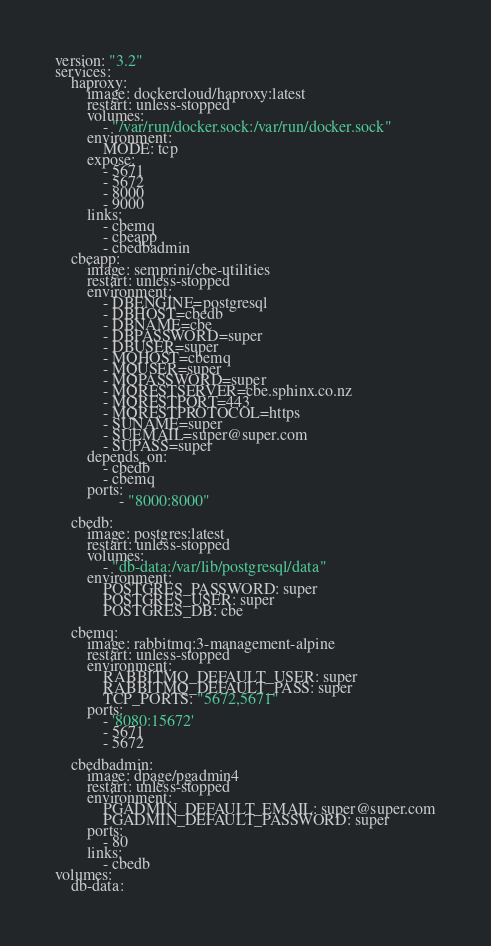<code> <loc_0><loc_0><loc_500><loc_500><_YAML_>version: "3.2"
services:
    haproxy:
        image: dockercloud/haproxy:latest
        restart: unless-stopped
        volumes:
            - "/var/run/docker.sock:/var/run/docker.sock"
        environment:
            MODE: tcp
        expose:
            - 5671
            - 5672
            - 8000
            - 9000
        links:
            - cbemq
            - cbeapp
            - cbedbadmin
    cbeapp:
        image: semprini/cbe-utilities
        restart: unless-stopped
        environment:
            - DBENGINE=postgresql
            - DBHOST=cbedb
            - DBNAME=cbe
            - DBPASSWORD=super
            - DBUSER=super
            - MQHOST=cbemq
            - MQUSER=super
            - MQPASSWORD=super
            - MQRESTSERVER=cbe.sphinx.co.nz
            - MQRESTPORT=443
            - MQRESTPROTOCOL=https
            - SUNAME=super
            - SUEMAIL=super@super.com
            - SUPASS=super
        depends_on:
            - cbedb
            - cbemq
        ports:
                - "8000:8000"
            
    cbedb:
        image: postgres:latest
        restart: unless-stopped
        volumes:
            - "db-data:/var/lib/postgresql/data"
        environment:
            POSTGRES_PASSWORD: super
            POSTGRES_USER: super
            POSTGRES_DB: cbe
            
    cbemq:
        image: rabbitmq:3-management-alpine
        restart: unless-stopped
        environment:
            RABBITMQ_DEFAULT_USER: super
            RABBITMQ_DEFAULT_PASS: super
            TCP_PORTS: "5672,5671"
        ports:
            - '8080:15672'
            - 5671
            - 5672

    cbedbadmin:
        image: dpage/pgadmin4
        restart: unless-stopped
        environment:
            PGADMIN_DEFAULT_EMAIL: super@super.com
            PGADMIN_DEFAULT_PASSWORD: super
        ports:
            - 80
        links:
            - cbedb
volumes:
    db-data:

</code> 